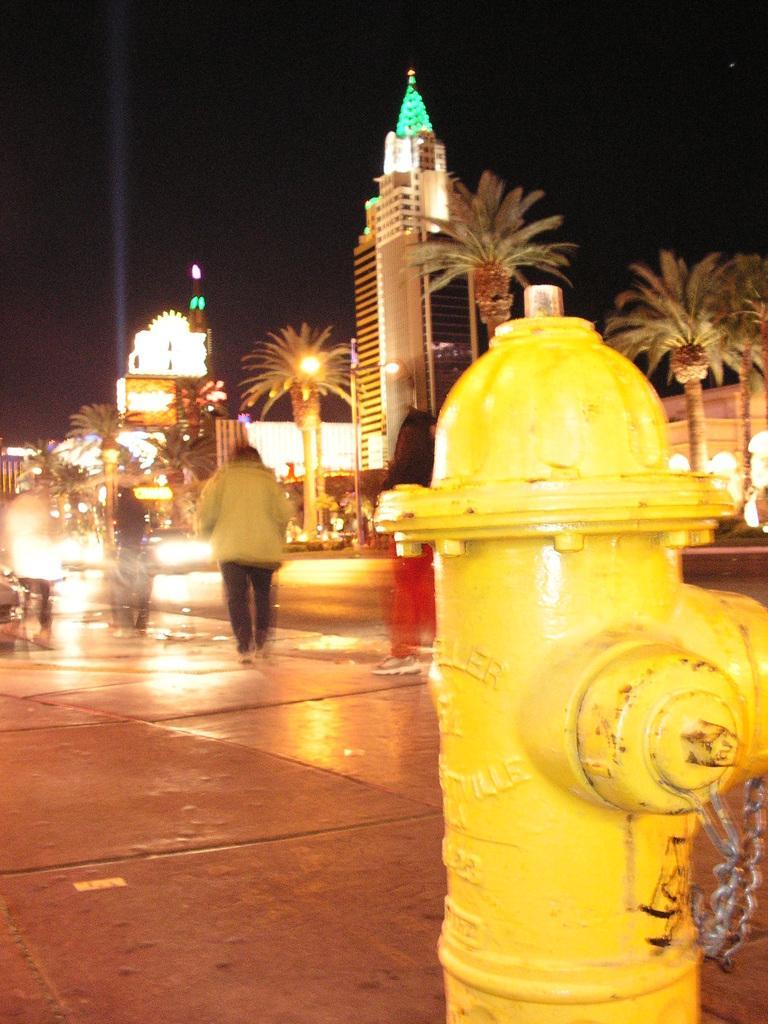How would you summarize this image in a sentence or two? In the foreground I can see a fire hydrant on the road. In the background I can see a crowd, trees, buildings and light poles. On the top I can see the sky. This image is taken during night. 